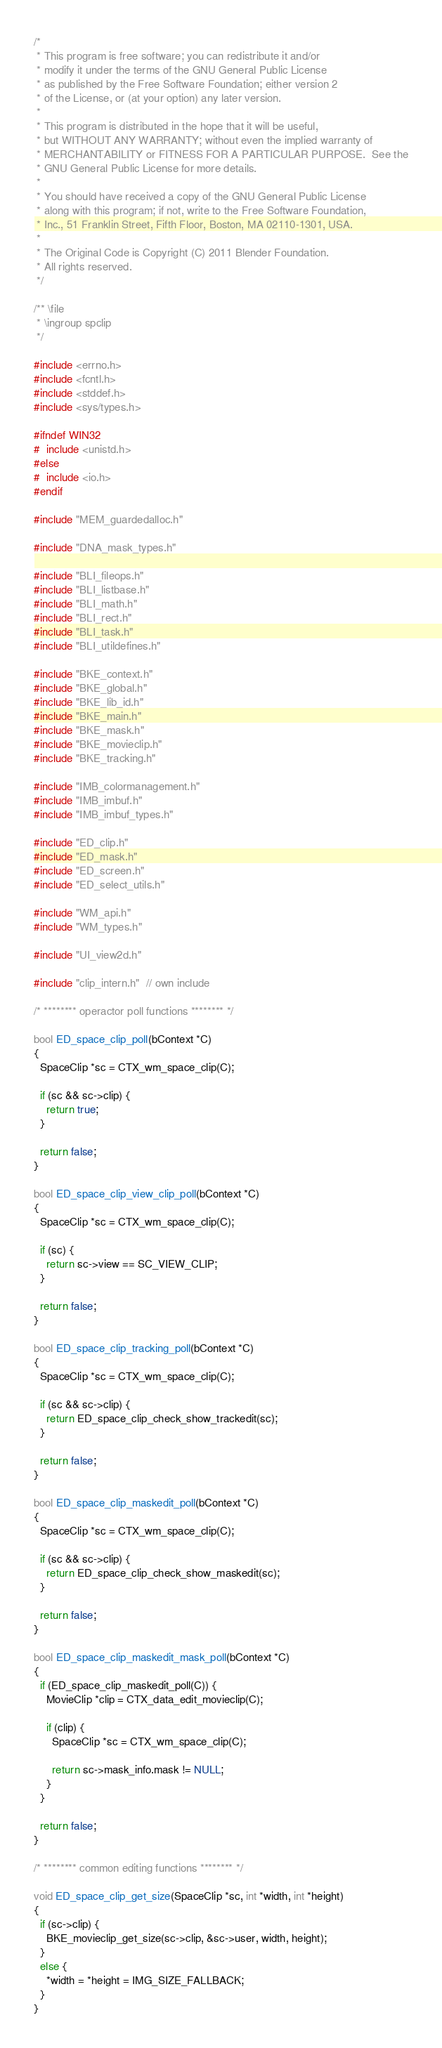<code> <loc_0><loc_0><loc_500><loc_500><_C_>/*
 * This program is free software; you can redistribute it and/or
 * modify it under the terms of the GNU General Public License
 * as published by the Free Software Foundation; either version 2
 * of the License, or (at your option) any later version.
 *
 * This program is distributed in the hope that it will be useful,
 * but WITHOUT ANY WARRANTY; without even the implied warranty of
 * MERCHANTABILITY or FITNESS FOR A PARTICULAR PURPOSE.  See the
 * GNU General Public License for more details.
 *
 * You should have received a copy of the GNU General Public License
 * along with this program; if not, write to the Free Software Foundation,
 * Inc., 51 Franklin Street, Fifth Floor, Boston, MA 02110-1301, USA.
 *
 * The Original Code is Copyright (C) 2011 Blender Foundation.
 * All rights reserved.
 */

/** \file
 * \ingroup spclip
 */

#include <errno.h>
#include <fcntl.h>
#include <stddef.h>
#include <sys/types.h>

#ifndef WIN32
#  include <unistd.h>
#else
#  include <io.h>
#endif

#include "MEM_guardedalloc.h"

#include "DNA_mask_types.h"

#include "BLI_fileops.h"
#include "BLI_listbase.h"
#include "BLI_math.h"
#include "BLI_rect.h"
#include "BLI_task.h"
#include "BLI_utildefines.h"

#include "BKE_context.h"
#include "BKE_global.h"
#include "BKE_lib_id.h"
#include "BKE_main.h"
#include "BKE_mask.h"
#include "BKE_movieclip.h"
#include "BKE_tracking.h"

#include "IMB_colormanagement.h"
#include "IMB_imbuf.h"
#include "IMB_imbuf_types.h"

#include "ED_clip.h"
#include "ED_mask.h"
#include "ED_screen.h"
#include "ED_select_utils.h"

#include "WM_api.h"
#include "WM_types.h"

#include "UI_view2d.h"

#include "clip_intern.h"  // own include

/* ******** operactor poll functions ******** */

bool ED_space_clip_poll(bContext *C)
{
  SpaceClip *sc = CTX_wm_space_clip(C);

  if (sc && sc->clip) {
    return true;
  }

  return false;
}

bool ED_space_clip_view_clip_poll(bContext *C)
{
  SpaceClip *sc = CTX_wm_space_clip(C);

  if (sc) {
    return sc->view == SC_VIEW_CLIP;
  }

  return false;
}

bool ED_space_clip_tracking_poll(bContext *C)
{
  SpaceClip *sc = CTX_wm_space_clip(C);

  if (sc && sc->clip) {
    return ED_space_clip_check_show_trackedit(sc);
  }

  return false;
}

bool ED_space_clip_maskedit_poll(bContext *C)
{
  SpaceClip *sc = CTX_wm_space_clip(C);

  if (sc && sc->clip) {
    return ED_space_clip_check_show_maskedit(sc);
  }

  return false;
}

bool ED_space_clip_maskedit_mask_poll(bContext *C)
{
  if (ED_space_clip_maskedit_poll(C)) {
    MovieClip *clip = CTX_data_edit_movieclip(C);

    if (clip) {
      SpaceClip *sc = CTX_wm_space_clip(C);

      return sc->mask_info.mask != NULL;
    }
  }

  return false;
}

/* ******** common editing functions ******** */

void ED_space_clip_get_size(SpaceClip *sc, int *width, int *height)
{
  if (sc->clip) {
    BKE_movieclip_get_size(sc->clip, &sc->user, width, height);
  }
  else {
    *width = *height = IMG_SIZE_FALLBACK;
  }
}
</code> 